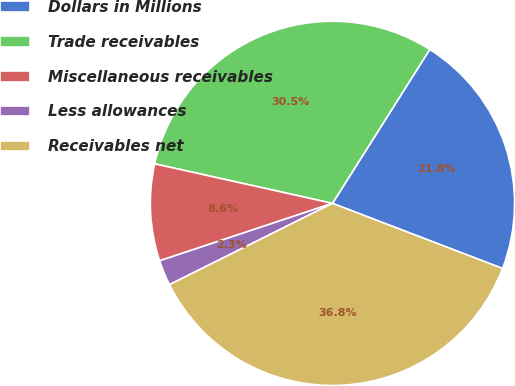<chart> <loc_0><loc_0><loc_500><loc_500><pie_chart><fcel>Dollars in Millions<fcel>Trade receivables<fcel>Miscellaneous receivables<fcel>Less allowances<fcel>Receivables net<nl><fcel>21.85%<fcel>30.49%<fcel>8.59%<fcel>2.26%<fcel>36.82%<nl></chart> 